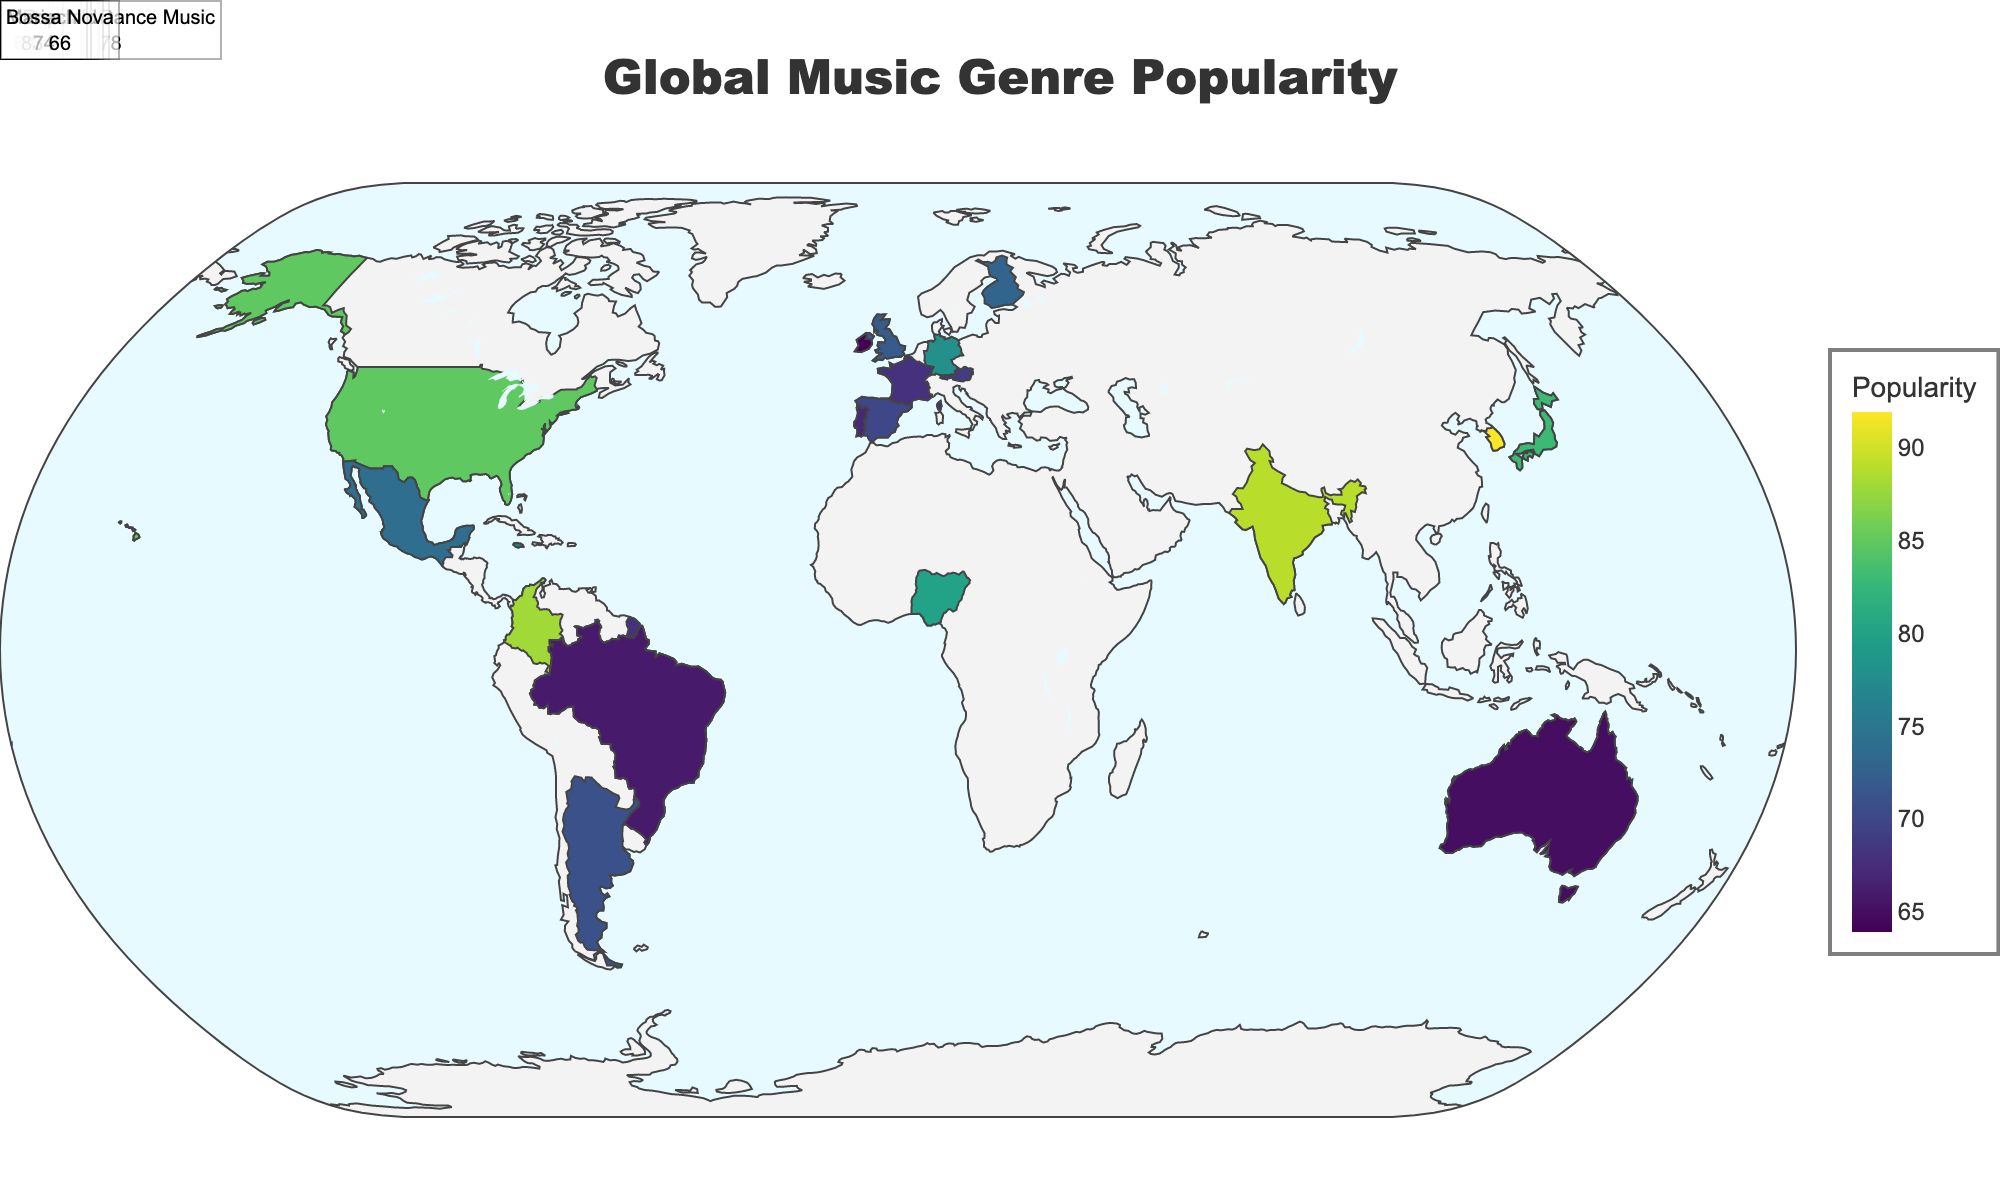What's the title of the figure? The title of a figure is typically located at the top center and is intended to provide a summary of the content of the figure. Here, the title is clearly visible at the top of the map.
Answer: Global Music Genre Popularity Which country has the highest popularity for a music genre, and what genre is it? To find the country with the highest popularity, look for the highest value under the "Popularity" attribute and check the corresponding "Country" and "Genre". In this case, it's South Korea with the genre K-Pop.
Answer: South Korea, K-Pop What color represents the least popular music genres in the figure? The color scale used to represent popularity ranges from dark to light. In this plot, the least popular genres are represented by the color corresponding to the lower end of the color scale, which is light in the Viridis color scale.
Answer: Light color How many countries have a genre popularity of more than 80? Count the number of countries where the "Popularity" value exceeds 80. These countries are the United States, South Korea, Colombia, Nigeria, and India, which makes it five countries.
Answer: 5 What's the popularity of Jazz in France in the figure? Locate France on the map and check the annotation/data point assigned to it. It indicates that Jazz in France has a popularity score provided in the plot annotations.
Answer: 68 Compare the popularity of Reggaeton in Colombia to Mariachi in Mexico. Which one is more popular? Locate both Colombia and Mexico on the map, then compare the popularity scores indicated for Reggaeton and Mariachi. Reggaeton in Colombia has a popularity of 88, while Mariachi in Mexico has a popularity of 74, making Reggaeton more popular.
Answer: Reggaeton in Colombia Which ocean color is used in the map background? Identify the color used for the ocean in the map's background. In this case, the ocean is colored a light blue/azure based on the description in the settings.
Answer: Light blue/azure What is the average popularity of the genres in Brazil? Find the genres and their respective popularity values in Brazil, which are Samba (75) and Bossa Nova (66). Calculate the average of these values: (75 + 66) / 2.
Answer: 70.5 Which European country has a higher popularity score: Metal in Finland or Flamenco in Spain? Locate Finland and Spain on the map, then compare the popularity scores of Metal in Finland (73) to Flamenco in Spain (70). Metal in Finland has a higher popularity score.
Answer: Finland (Metal) What's the difference in popularity between K-Pop in South Korea and J-Pop in Japan? To find the difference, subtract the popularity of J-Pop in Japan from K-Pop in South Korea: 92 (K-Pop) - 83 (J-Pop). This equals 9.
Answer: 9 